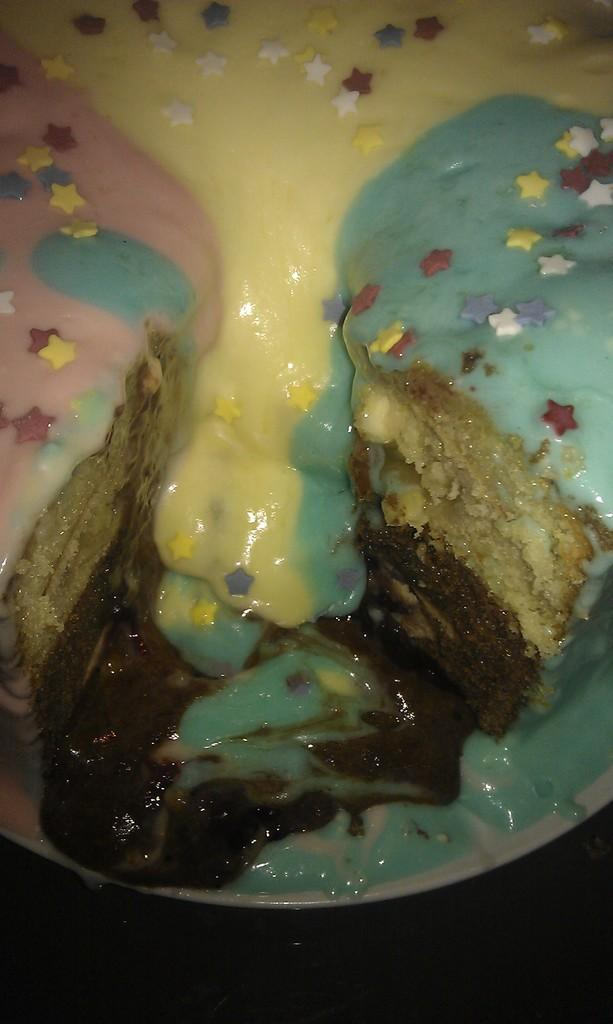What is the main subject of the image? There is a cake in the image. How is the cake presented? The cake is on a plate. What is a noticeable feature of the cake? There is cream on the cake. Can you describe the appearance of the bottom of the image? The bottom of the image is dark. What type of shoes can be seen on the cake in the image? There are no shoes present on the cake in the image. Can you describe the seat that is visible in the image? There is no seat visible in the image; it only features a cake on a plate. 